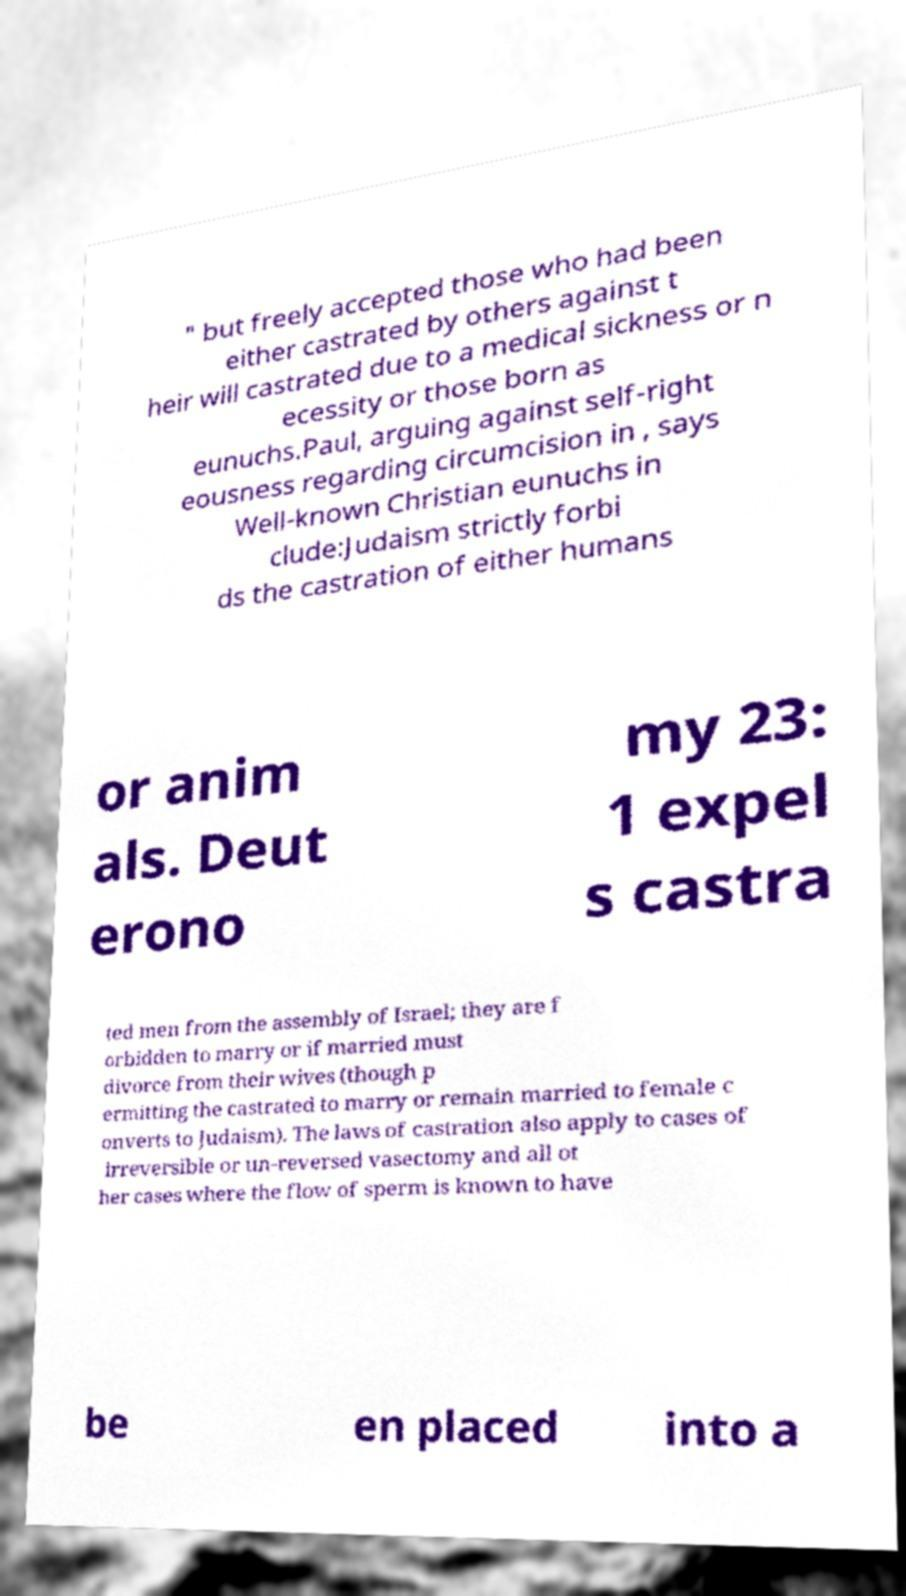Can you accurately transcribe the text from the provided image for me? " but freely accepted those who had been either castrated by others against t heir will castrated due to a medical sickness or n ecessity or those born as eunuchs.Paul, arguing against self-right eousness regarding circumcision in , says Well-known Christian eunuchs in clude:Judaism strictly forbi ds the castration of either humans or anim als. Deut erono my 23: 1 expel s castra ted men from the assembly of Israel; they are f orbidden to marry or if married must divorce from their wives (though p ermitting the castrated to marry or remain married to female c onverts to Judaism). The laws of castration also apply to cases of irreversible or un-reversed vasectomy and all ot her cases where the flow of sperm is known to have be en placed into a 